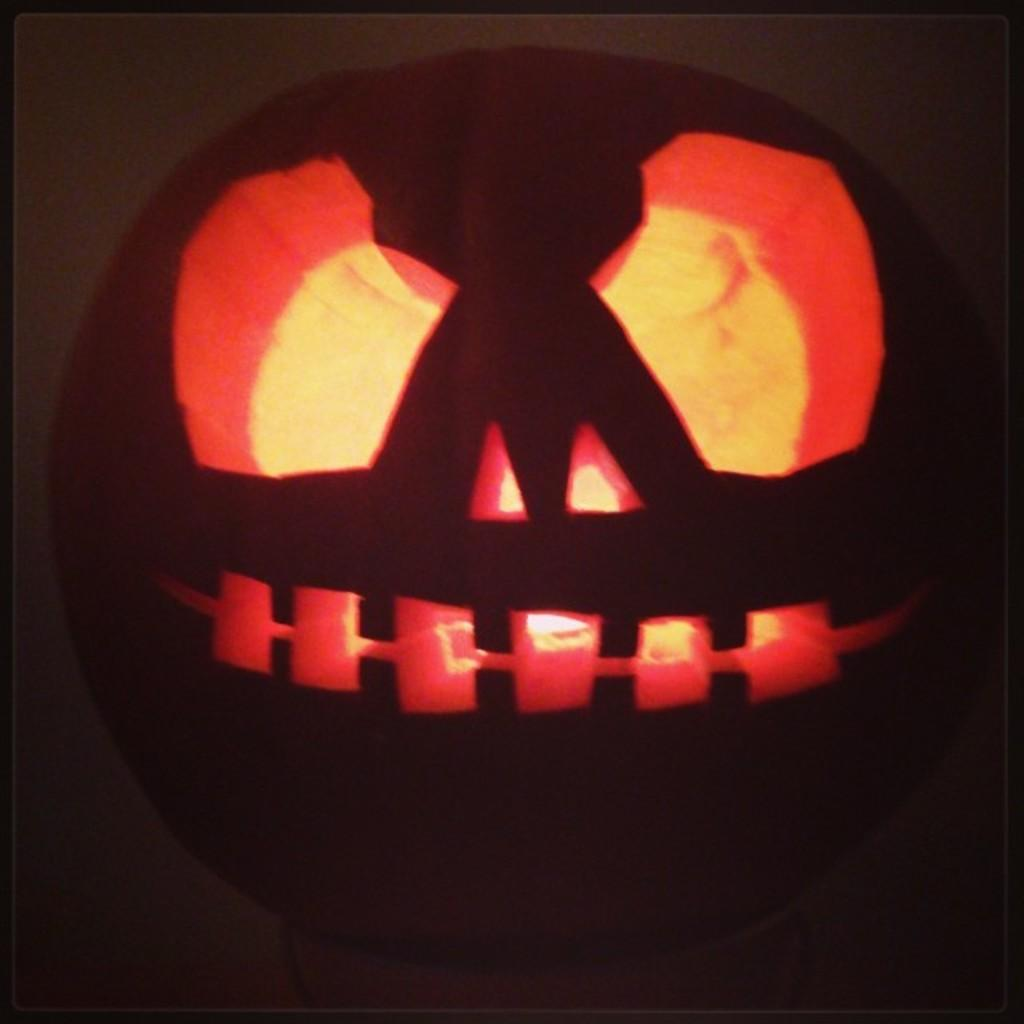What is the main object in the image? There is a pumpkin in the image. What type of hat can be seen on the coast in the image? There is no hat or coast present in the image; it only features a pumpkin. 